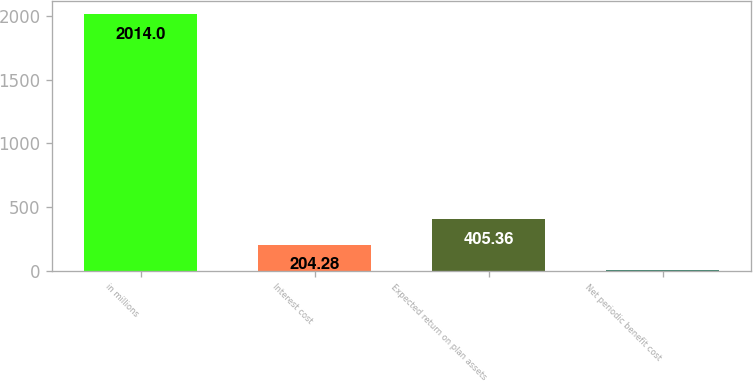<chart> <loc_0><loc_0><loc_500><loc_500><bar_chart><fcel>in millions<fcel>Interest cost<fcel>Expected return on plan assets<fcel>Net periodic benefit cost<nl><fcel>2014<fcel>204.28<fcel>405.36<fcel>3.2<nl></chart> 